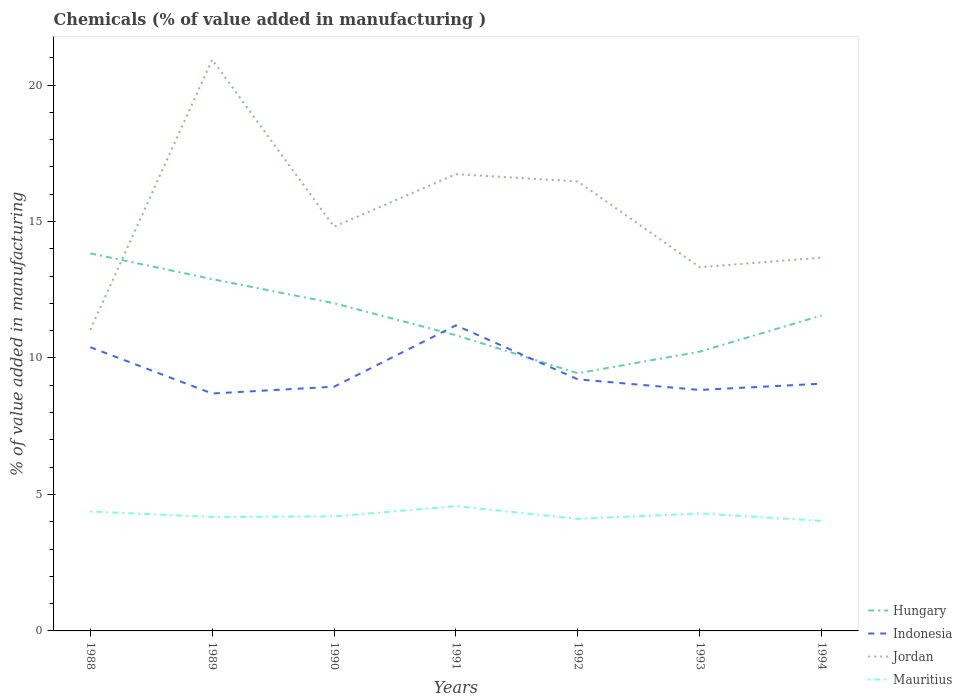Is the number of lines equal to the number of legend labels?
Keep it short and to the point. Yes. Across all years, what is the maximum value added in manufacturing chemicals in Hungary?
Your answer should be very brief. 9.44. What is the total value added in manufacturing chemicals in Hungary in the graph?
Offer a very short reply. -0.79. What is the difference between the highest and the second highest value added in manufacturing chemicals in Indonesia?
Your answer should be compact. 2.5. Is the value added in manufacturing chemicals in Hungary strictly greater than the value added in manufacturing chemicals in Jordan over the years?
Make the answer very short. No. How many lines are there?
Give a very brief answer. 4. Are the values on the major ticks of Y-axis written in scientific E-notation?
Offer a very short reply. No. Does the graph contain any zero values?
Give a very brief answer. No. Does the graph contain grids?
Keep it short and to the point. No. How many legend labels are there?
Provide a succinct answer. 4. How are the legend labels stacked?
Offer a terse response. Vertical. What is the title of the graph?
Give a very brief answer. Chemicals (% of value added in manufacturing ). Does "Belarus" appear as one of the legend labels in the graph?
Provide a short and direct response. No. What is the label or title of the Y-axis?
Offer a very short reply. % of value added in manufacturing. What is the % of value added in manufacturing in Hungary in 1988?
Ensure brevity in your answer.  13.83. What is the % of value added in manufacturing of Indonesia in 1988?
Make the answer very short. 10.4. What is the % of value added in manufacturing in Jordan in 1988?
Offer a terse response. 11.03. What is the % of value added in manufacturing in Mauritius in 1988?
Keep it short and to the point. 4.38. What is the % of value added in manufacturing of Hungary in 1989?
Your response must be concise. 12.89. What is the % of value added in manufacturing in Indonesia in 1989?
Your answer should be compact. 8.7. What is the % of value added in manufacturing in Jordan in 1989?
Offer a terse response. 20.93. What is the % of value added in manufacturing of Mauritius in 1989?
Your response must be concise. 4.17. What is the % of value added in manufacturing of Hungary in 1990?
Make the answer very short. 12.01. What is the % of value added in manufacturing in Indonesia in 1990?
Offer a terse response. 8.95. What is the % of value added in manufacturing of Jordan in 1990?
Your answer should be compact. 14.81. What is the % of value added in manufacturing of Mauritius in 1990?
Your answer should be compact. 4.2. What is the % of value added in manufacturing of Hungary in 1991?
Your answer should be compact. 10.83. What is the % of value added in manufacturing of Indonesia in 1991?
Make the answer very short. 11.2. What is the % of value added in manufacturing of Jordan in 1991?
Offer a terse response. 16.74. What is the % of value added in manufacturing of Mauritius in 1991?
Ensure brevity in your answer.  4.57. What is the % of value added in manufacturing of Hungary in 1992?
Make the answer very short. 9.44. What is the % of value added in manufacturing of Indonesia in 1992?
Provide a short and direct response. 9.22. What is the % of value added in manufacturing of Jordan in 1992?
Your response must be concise. 16.47. What is the % of value added in manufacturing of Mauritius in 1992?
Ensure brevity in your answer.  4.11. What is the % of value added in manufacturing of Hungary in 1993?
Your answer should be compact. 10.23. What is the % of value added in manufacturing of Indonesia in 1993?
Provide a short and direct response. 8.83. What is the % of value added in manufacturing of Jordan in 1993?
Your answer should be very brief. 13.33. What is the % of value added in manufacturing in Mauritius in 1993?
Your answer should be very brief. 4.31. What is the % of value added in manufacturing in Hungary in 1994?
Your answer should be very brief. 11.56. What is the % of value added in manufacturing in Indonesia in 1994?
Provide a short and direct response. 9.06. What is the % of value added in manufacturing in Jordan in 1994?
Your answer should be compact. 13.68. What is the % of value added in manufacturing of Mauritius in 1994?
Your response must be concise. 4.03. Across all years, what is the maximum % of value added in manufacturing of Hungary?
Your answer should be compact. 13.83. Across all years, what is the maximum % of value added in manufacturing in Indonesia?
Offer a very short reply. 11.2. Across all years, what is the maximum % of value added in manufacturing of Jordan?
Make the answer very short. 20.93. Across all years, what is the maximum % of value added in manufacturing in Mauritius?
Provide a short and direct response. 4.57. Across all years, what is the minimum % of value added in manufacturing of Hungary?
Your answer should be compact. 9.44. Across all years, what is the minimum % of value added in manufacturing of Indonesia?
Give a very brief answer. 8.7. Across all years, what is the minimum % of value added in manufacturing of Jordan?
Your answer should be compact. 11.03. Across all years, what is the minimum % of value added in manufacturing in Mauritius?
Ensure brevity in your answer.  4.03. What is the total % of value added in manufacturing of Hungary in the graph?
Provide a succinct answer. 80.8. What is the total % of value added in manufacturing of Indonesia in the graph?
Make the answer very short. 66.35. What is the total % of value added in manufacturing of Jordan in the graph?
Offer a terse response. 106.98. What is the total % of value added in manufacturing of Mauritius in the graph?
Your response must be concise. 29.76. What is the difference between the % of value added in manufacturing in Hungary in 1988 and that in 1989?
Provide a succinct answer. 0.94. What is the difference between the % of value added in manufacturing in Indonesia in 1988 and that in 1989?
Your answer should be very brief. 1.7. What is the difference between the % of value added in manufacturing of Jordan in 1988 and that in 1989?
Offer a very short reply. -9.9. What is the difference between the % of value added in manufacturing in Mauritius in 1988 and that in 1989?
Make the answer very short. 0.2. What is the difference between the % of value added in manufacturing of Hungary in 1988 and that in 1990?
Provide a short and direct response. 1.83. What is the difference between the % of value added in manufacturing of Indonesia in 1988 and that in 1990?
Offer a very short reply. 1.45. What is the difference between the % of value added in manufacturing in Jordan in 1988 and that in 1990?
Make the answer very short. -3.78. What is the difference between the % of value added in manufacturing of Mauritius in 1988 and that in 1990?
Your answer should be compact. 0.18. What is the difference between the % of value added in manufacturing of Hungary in 1988 and that in 1991?
Offer a very short reply. 3. What is the difference between the % of value added in manufacturing of Indonesia in 1988 and that in 1991?
Offer a terse response. -0.8. What is the difference between the % of value added in manufacturing in Jordan in 1988 and that in 1991?
Keep it short and to the point. -5.7. What is the difference between the % of value added in manufacturing in Mauritius in 1988 and that in 1991?
Your response must be concise. -0.2. What is the difference between the % of value added in manufacturing in Hungary in 1988 and that in 1992?
Offer a very short reply. 4.39. What is the difference between the % of value added in manufacturing in Indonesia in 1988 and that in 1992?
Keep it short and to the point. 1.18. What is the difference between the % of value added in manufacturing in Jordan in 1988 and that in 1992?
Offer a terse response. -5.44. What is the difference between the % of value added in manufacturing in Mauritius in 1988 and that in 1992?
Ensure brevity in your answer.  0.27. What is the difference between the % of value added in manufacturing in Hungary in 1988 and that in 1993?
Your answer should be very brief. 3.6. What is the difference between the % of value added in manufacturing in Indonesia in 1988 and that in 1993?
Provide a short and direct response. 1.57. What is the difference between the % of value added in manufacturing of Jordan in 1988 and that in 1993?
Offer a very short reply. -2.29. What is the difference between the % of value added in manufacturing of Mauritius in 1988 and that in 1993?
Make the answer very short. 0.07. What is the difference between the % of value added in manufacturing in Hungary in 1988 and that in 1994?
Provide a succinct answer. 2.28. What is the difference between the % of value added in manufacturing in Indonesia in 1988 and that in 1994?
Offer a terse response. 1.34. What is the difference between the % of value added in manufacturing in Jordan in 1988 and that in 1994?
Keep it short and to the point. -2.65. What is the difference between the % of value added in manufacturing of Mauritius in 1988 and that in 1994?
Provide a short and direct response. 0.34. What is the difference between the % of value added in manufacturing in Hungary in 1989 and that in 1990?
Your answer should be very brief. 0.88. What is the difference between the % of value added in manufacturing in Indonesia in 1989 and that in 1990?
Provide a succinct answer. -0.25. What is the difference between the % of value added in manufacturing in Jordan in 1989 and that in 1990?
Offer a very short reply. 6.12. What is the difference between the % of value added in manufacturing in Mauritius in 1989 and that in 1990?
Your answer should be compact. -0.02. What is the difference between the % of value added in manufacturing in Hungary in 1989 and that in 1991?
Ensure brevity in your answer.  2.06. What is the difference between the % of value added in manufacturing of Indonesia in 1989 and that in 1991?
Make the answer very short. -2.5. What is the difference between the % of value added in manufacturing of Jordan in 1989 and that in 1991?
Offer a terse response. 4.2. What is the difference between the % of value added in manufacturing in Mauritius in 1989 and that in 1991?
Provide a succinct answer. -0.4. What is the difference between the % of value added in manufacturing in Hungary in 1989 and that in 1992?
Provide a short and direct response. 3.45. What is the difference between the % of value added in manufacturing of Indonesia in 1989 and that in 1992?
Your response must be concise. -0.52. What is the difference between the % of value added in manufacturing in Jordan in 1989 and that in 1992?
Provide a short and direct response. 4.46. What is the difference between the % of value added in manufacturing of Mauritius in 1989 and that in 1992?
Your response must be concise. 0.07. What is the difference between the % of value added in manufacturing in Hungary in 1989 and that in 1993?
Offer a terse response. 2.66. What is the difference between the % of value added in manufacturing of Indonesia in 1989 and that in 1993?
Ensure brevity in your answer.  -0.13. What is the difference between the % of value added in manufacturing in Jordan in 1989 and that in 1993?
Your answer should be very brief. 7.61. What is the difference between the % of value added in manufacturing of Mauritius in 1989 and that in 1993?
Offer a terse response. -0.13. What is the difference between the % of value added in manufacturing of Hungary in 1989 and that in 1994?
Your answer should be compact. 1.33. What is the difference between the % of value added in manufacturing in Indonesia in 1989 and that in 1994?
Make the answer very short. -0.36. What is the difference between the % of value added in manufacturing of Jordan in 1989 and that in 1994?
Provide a succinct answer. 7.25. What is the difference between the % of value added in manufacturing in Mauritius in 1989 and that in 1994?
Your response must be concise. 0.14. What is the difference between the % of value added in manufacturing of Hungary in 1990 and that in 1991?
Give a very brief answer. 1.17. What is the difference between the % of value added in manufacturing of Indonesia in 1990 and that in 1991?
Provide a succinct answer. -2.25. What is the difference between the % of value added in manufacturing in Jordan in 1990 and that in 1991?
Offer a very short reply. -1.93. What is the difference between the % of value added in manufacturing of Mauritius in 1990 and that in 1991?
Provide a succinct answer. -0.38. What is the difference between the % of value added in manufacturing of Hungary in 1990 and that in 1992?
Make the answer very short. 2.57. What is the difference between the % of value added in manufacturing of Indonesia in 1990 and that in 1992?
Your answer should be compact. -0.27. What is the difference between the % of value added in manufacturing in Jordan in 1990 and that in 1992?
Your response must be concise. -1.66. What is the difference between the % of value added in manufacturing in Mauritius in 1990 and that in 1992?
Ensure brevity in your answer.  0.09. What is the difference between the % of value added in manufacturing of Hungary in 1990 and that in 1993?
Your response must be concise. 1.77. What is the difference between the % of value added in manufacturing of Indonesia in 1990 and that in 1993?
Your response must be concise. 0.12. What is the difference between the % of value added in manufacturing in Jordan in 1990 and that in 1993?
Provide a succinct answer. 1.48. What is the difference between the % of value added in manufacturing in Mauritius in 1990 and that in 1993?
Offer a terse response. -0.11. What is the difference between the % of value added in manufacturing in Hungary in 1990 and that in 1994?
Provide a short and direct response. 0.45. What is the difference between the % of value added in manufacturing of Indonesia in 1990 and that in 1994?
Give a very brief answer. -0.11. What is the difference between the % of value added in manufacturing of Jordan in 1990 and that in 1994?
Offer a terse response. 1.13. What is the difference between the % of value added in manufacturing of Mauritius in 1990 and that in 1994?
Offer a terse response. 0.16. What is the difference between the % of value added in manufacturing in Hungary in 1991 and that in 1992?
Your answer should be very brief. 1.39. What is the difference between the % of value added in manufacturing in Indonesia in 1991 and that in 1992?
Give a very brief answer. 1.98. What is the difference between the % of value added in manufacturing of Jordan in 1991 and that in 1992?
Your answer should be compact. 0.27. What is the difference between the % of value added in manufacturing in Mauritius in 1991 and that in 1992?
Provide a short and direct response. 0.47. What is the difference between the % of value added in manufacturing of Hungary in 1991 and that in 1993?
Provide a short and direct response. 0.6. What is the difference between the % of value added in manufacturing in Indonesia in 1991 and that in 1993?
Provide a succinct answer. 2.37. What is the difference between the % of value added in manufacturing in Jordan in 1991 and that in 1993?
Your answer should be very brief. 3.41. What is the difference between the % of value added in manufacturing in Mauritius in 1991 and that in 1993?
Your answer should be compact. 0.27. What is the difference between the % of value added in manufacturing in Hungary in 1991 and that in 1994?
Ensure brevity in your answer.  -0.72. What is the difference between the % of value added in manufacturing of Indonesia in 1991 and that in 1994?
Make the answer very short. 2.14. What is the difference between the % of value added in manufacturing in Jordan in 1991 and that in 1994?
Make the answer very short. 3.06. What is the difference between the % of value added in manufacturing of Mauritius in 1991 and that in 1994?
Make the answer very short. 0.54. What is the difference between the % of value added in manufacturing in Hungary in 1992 and that in 1993?
Your answer should be compact. -0.79. What is the difference between the % of value added in manufacturing of Indonesia in 1992 and that in 1993?
Provide a succinct answer. 0.39. What is the difference between the % of value added in manufacturing of Jordan in 1992 and that in 1993?
Provide a succinct answer. 3.14. What is the difference between the % of value added in manufacturing in Mauritius in 1992 and that in 1993?
Offer a terse response. -0.2. What is the difference between the % of value added in manufacturing in Hungary in 1992 and that in 1994?
Provide a succinct answer. -2.12. What is the difference between the % of value added in manufacturing of Indonesia in 1992 and that in 1994?
Offer a terse response. 0.16. What is the difference between the % of value added in manufacturing in Jordan in 1992 and that in 1994?
Give a very brief answer. 2.79. What is the difference between the % of value added in manufacturing of Mauritius in 1992 and that in 1994?
Offer a terse response. 0.07. What is the difference between the % of value added in manufacturing in Hungary in 1993 and that in 1994?
Ensure brevity in your answer.  -1.33. What is the difference between the % of value added in manufacturing in Indonesia in 1993 and that in 1994?
Ensure brevity in your answer.  -0.23. What is the difference between the % of value added in manufacturing in Jordan in 1993 and that in 1994?
Provide a succinct answer. -0.35. What is the difference between the % of value added in manufacturing in Mauritius in 1993 and that in 1994?
Keep it short and to the point. 0.27. What is the difference between the % of value added in manufacturing of Hungary in 1988 and the % of value added in manufacturing of Indonesia in 1989?
Give a very brief answer. 5.13. What is the difference between the % of value added in manufacturing in Hungary in 1988 and the % of value added in manufacturing in Jordan in 1989?
Provide a succinct answer. -7.1. What is the difference between the % of value added in manufacturing in Hungary in 1988 and the % of value added in manufacturing in Mauritius in 1989?
Give a very brief answer. 9.66. What is the difference between the % of value added in manufacturing in Indonesia in 1988 and the % of value added in manufacturing in Jordan in 1989?
Make the answer very short. -10.54. What is the difference between the % of value added in manufacturing in Indonesia in 1988 and the % of value added in manufacturing in Mauritius in 1989?
Make the answer very short. 6.22. What is the difference between the % of value added in manufacturing of Jordan in 1988 and the % of value added in manufacturing of Mauritius in 1989?
Provide a succinct answer. 6.86. What is the difference between the % of value added in manufacturing of Hungary in 1988 and the % of value added in manufacturing of Indonesia in 1990?
Your answer should be compact. 4.89. What is the difference between the % of value added in manufacturing of Hungary in 1988 and the % of value added in manufacturing of Jordan in 1990?
Make the answer very short. -0.97. What is the difference between the % of value added in manufacturing in Hungary in 1988 and the % of value added in manufacturing in Mauritius in 1990?
Your response must be concise. 9.64. What is the difference between the % of value added in manufacturing in Indonesia in 1988 and the % of value added in manufacturing in Jordan in 1990?
Ensure brevity in your answer.  -4.41. What is the difference between the % of value added in manufacturing of Indonesia in 1988 and the % of value added in manufacturing of Mauritius in 1990?
Offer a terse response. 6.2. What is the difference between the % of value added in manufacturing of Jordan in 1988 and the % of value added in manufacturing of Mauritius in 1990?
Give a very brief answer. 6.84. What is the difference between the % of value added in manufacturing of Hungary in 1988 and the % of value added in manufacturing of Indonesia in 1991?
Give a very brief answer. 2.64. What is the difference between the % of value added in manufacturing in Hungary in 1988 and the % of value added in manufacturing in Jordan in 1991?
Your answer should be very brief. -2.9. What is the difference between the % of value added in manufacturing in Hungary in 1988 and the % of value added in manufacturing in Mauritius in 1991?
Ensure brevity in your answer.  9.26. What is the difference between the % of value added in manufacturing in Indonesia in 1988 and the % of value added in manufacturing in Jordan in 1991?
Ensure brevity in your answer.  -6.34. What is the difference between the % of value added in manufacturing of Indonesia in 1988 and the % of value added in manufacturing of Mauritius in 1991?
Provide a short and direct response. 5.82. What is the difference between the % of value added in manufacturing of Jordan in 1988 and the % of value added in manufacturing of Mauritius in 1991?
Ensure brevity in your answer.  6.46. What is the difference between the % of value added in manufacturing of Hungary in 1988 and the % of value added in manufacturing of Indonesia in 1992?
Offer a terse response. 4.62. What is the difference between the % of value added in manufacturing in Hungary in 1988 and the % of value added in manufacturing in Jordan in 1992?
Your answer should be compact. -2.63. What is the difference between the % of value added in manufacturing of Hungary in 1988 and the % of value added in manufacturing of Mauritius in 1992?
Make the answer very short. 9.73. What is the difference between the % of value added in manufacturing of Indonesia in 1988 and the % of value added in manufacturing of Jordan in 1992?
Your answer should be very brief. -6.07. What is the difference between the % of value added in manufacturing of Indonesia in 1988 and the % of value added in manufacturing of Mauritius in 1992?
Keep it short and to the point. 6.29. What is the difference between the % of value added in manufacturing in Jordan in 1988 and the % of value added in manufacturing in Mauritius in 1992?
Offer a very short reply. 6.93. What is the difference between the % of value added in manufacturing of Hungary in 1988 and the % of value added in manufacturing of Indonesia in 1993?
Keep it short and to the point. 5. What is the difference between the % of value added in manufacturing of Hungary in 1988 and the % of value added in manufacturing of Jordan in 1993?
Keep it short and to the point. 0.51. What is the difference between the % of value added in manufacturing in Hungary in 1988 and the % of value added in manufacturing in Mauritius in 1993?
Provide a succinct answer. 9.53. What is the difference between the % of value added in manufacturing of Indonesia in 1988 and the % of value added in manufacturing of Jordan in 1993?
Your response must be concise. -2.93. What is the difference between the % of value added in manufacturing of Indonesia in 1988 and the % of value added in manufacturing of Mauritius in 1993?
Provide a succinct answer. 6.09. What is the difference between the % of value added in manufacturing of Jordan in 1988 and the % of value added in manufacturing of Mauritius in 1993?
Give a very brief answer. 6.73. What is the difference between the % of value added in manufacturing of Hungary in 1988 and the % of value added in manufacturing of Indonesia in 1994?
Provide a short and direct response. 4.77. What is the difference between the % of value added in manufacturing of Hungary in 1988 and the % of value added in manufacturing of Jordan in 1994?
Provide a short and direct response. 0.16. What is the difference between the % of value added in manufacturing in Hungary in 1988 and the % of value added in manufacturing in Mauritius in 1994?
Offer a terse response. 9.8. What is the difference between the % of value added in manufacturing of Indonesia in 1988 and the % of value added in manufacturing of Jordan in 1994?
Provide a short and direct response. -3.28. What is the difference between the % of value added in manufacturing of Indonesia in 1988 and the % of value added in manufacturing of Mauritius in 1994?
Your answer should be very brief. 6.36. What is the difference between the % of value added in manufacturing of Jordan in 1988 and the % of value added in manufacturing of Mauritius in 1994?
Ensure brevity in your answer.  7. What is the difference between the % of value added in manufacturing of Hungary in 1989 and the % of value added in manufacturing of Indonesia in 1990?
Give a very brief answer. 3.94. What is the difference between the % of value added in manufacturing of Hungary in 1989 and the % of value added in manufacturing of Jordan in 1990?
Your answer should be compact. -1.92. What is the difference between the % of value added in manufacturing in Hungary in 1989 and the % of value added in manufacturing in Mauritius in 1990?
Make the answer very short. 8.69. What is the difference between the % of value added in manufacturing in Indonesia in 1989 and the % of value added in manufacturing in Jordan in 1990?
Ensure brevity in your answer.  -6.11. What is the difference between the % of value added in manufacturing of Indonesia in 1989 and the % of value added in manufacturing of Mauritius in 1990?
Make the answer very short. 4.5. What is the difference between the % of value added in manufacturing of Jordan in 1989 and the % of value added in manufacturing of Mauritius in 1990?
Your answer should be very brief. 16.74. What is the difference between the % of value added in manufacturing in Hungary in 1989 and the % of value added in manufacturing in Indonesia in 1991?
Give a very brief answer. 1.69. What is the difference between the % of value added in manufacturing in Hungary in 1989 and the % of value added in manufacturing in Jordan in 1991?
Your response must be concise. -3.85. What is the difference between the % of value added in manufacturing of Hungary in 1989 and the % of value added in manufacturing of Mauritius in 1991?
Offer a terse response. 8.32. What is the difference between the % of value added in manufacturing in Indonesia in 1989 and the % of value added in manufacturing in Jordan in 1991?
Your response must be concise. -8.04. What is the difference between the % of value added in manufacturing in Indonesia in 1989 and the % of value added in manufacturing in Mauritius in 1991?
Offer a very short reply. 4.13. What is the difference between the % of value added in manufacturing of Jordan in 1989 and the % of value added in manufacturing of Mauritius in 1991?
Make the answer very short. 16.36. What is the difference between the % of value added in manufacturing in Hungary in 1989 and the % of value added in manufacturing in Indonesia in 1992?
Offer a terse response. 3.67. What is the difference between the % of value added in manufacturing in Hungary in 1989 and the % of value added in manufacturing in Jordan in 1992?
Your answer should be very brief. -3.58. What is the difference between the % of value added in manufacturing in Hungary in 1989 and the % of value added in manufacturing in Mauritius in 1992?
Offer a terse response. 8.78. What is the difference between the % of value added in manufacturing of Indonesia in 1989 and the % of value added in manufacturing of Jordan in 1992?
Keep it short and to the point. -7.77. What is the difference between the % of value added in manufacturing of Indonesia in 1989 and the % of value added in manufacturing of Mauritius in 1992?
Provide a short and direct response. 4.59. What is the difference between the % of value added in manufacturing in Jordan in 1989 and the % of value added in manufacturing in Mauritius in 1992?
Offer a terse response. 16.83. What is the difference between the % of value added in manufacturing in Hungary in 1989 and the % of value added in manufacturing in Indonesia in 1993?
Offer a very short reply. 4.06. What is the difference between the % of value added in manufacturing of Hungary in 1989 and the % of value added in manufacturing of Jordan in 1993?
Offer a very short reply. -0.44. What is the difference between the % of value added in manufacturing in Hungary in 1989 and the % of value added in manufacturing in Mauritius in 1993?
Your response must be concise. 8.59. What is the difference between the % of value added in manufacturing of Indonesia in 1989 and the % of value added in manufacturing of Jordan in 1993?
Your answer should be compact. -4.63. What is the difference between the % of value added in manufacturing of Indonesia in 1989 and the % of value added in manufacturing of Mauritius in 1993?
Your answer should be compact. 4.39. What is the difference between the % of value added in manufacturing in Jordan in 1989 and the % of value added in manufacturing in Mauritius in 1993?
Your answer should be very brief. 16.63. What is the difference between the % of value added in manufacturing of Hungary in 1989 and the % of value added in manufacturing of Indonesia in 1994?
Offer a terse response. 3.83. What is the difference between the % of value added in manufacturing in Hungary in 1989 and the % of value added in manufacturing in Jordan in 1994?
Provide a succinct answer. -0.79. What is the difference between the % of value added in manufacturing in Hungary in 1989 and the % of value added in manufacturing in Mauritius in 1994?
Your answer should be very brief. 8.86. What is the difference between the % of value added in manufacturing of Indonesia in 1989 and the % of value added in manufacturing of Jordan in 1994?
Ensure brevity in your answer.  -4.98. What is the difference between the % of value added in manufacturing in Indonesia in 1989 and the % of value added in manufacturing in Mauritius in 1994?
Your answer should be compact. 4.67. What is the difference between the % of value added in manufacturing of Jordan in 1989 and the % of value added in manufacturing of Mauritius in 1994?
Give a very brief answer. 16.9. What is the difference between the % of value added in manufacturing of Hungary in 1990 and the % of value added in manufacturing of Indonesia in 1991?
Your answer should be very brief. 0.81. What is the difference between the % of value added in manufacturing of Hungary in 1990 and the % of value added in manufacturing of Jordan in 1991?
Your answer should be compact. -4.73. What is the difference between the % of value added in manufacturing in Hungary in 1990 and the % of value added in manufacturing in Mauritius in 1991?
Make the answer very short. 7.43. What is the difference between the % of value added in manufacturing in Indonesia in 1990 and the % of value added in manufacturing in Jordan in 1991?
Provide a short and direct response. -7.79. What is the difference between the % of value added in manufacturing in Indonesia in 1990 and the % of value added in manufacturing in Mauritius in 1991?
Give a very brief answer. 4.37. What is the difference between the % of value added in manufacturing of Jordan in 1990 and the % of value added in manufacturing of Mauritius in 1991?
Offer a very short reply. 10.23. What is the difference between the % of value added in manufacturing in Hungary in 1990 and the % of value added in manufacturing in Indonesia in 1992?
Offer a very short reply. 2.79. What is the difference between the % of value added in manufacturing in Hungary in 1990 and the % of value added in manufacturing in Jordan in 1992?
Make the answer very short. -4.46. What is the difference between the % of value added in manufacturing of Hungary in 1990 and the % of value added in manufacturing of Mauritius in 1992?
Give a very brief answer. 7.9. What is the difference between the % of value added in manufacturing of Indonesia in 1990 and the % of value added in manufacturing of Jordan in 1992?
Make the answer very short. -7.52. What is the difference between the % of value added in manufacturing in Indonesia in 1990 and the % of value added in manufacturing in Mauritius in 1992?
Your response must be concise. 4.84. What is the difference between the % of value added in manufacturing of Jordan in 1990 and the % of value added in manufacturing of Mauritius in 1992?
Your answer should be very brief. 10.7. What is the difference between the % of value added in manufacturing in Hungary in 1990 and the % of value added in manufacturing in Indonesia in 1993?
Ensure brevity in your answer.  3.18. What is the difference between the % of value added in manufacturing of Hungary in 1990 and the % of value added in manufacturing of Jordan in 1993?
Provide a short and direct response. -1.32. What is the difference between the % of value added in manufacturing in Hungary in 1990 and the % of value added in manufacturing in Mauritius in 1993?
Ensure brevity in your answer.  7.7. What is the difference between the % of value added in manufacturing in Indonesia in 1990 and the % of value added in manufacturing in Jordan in 1993?
Give a very brief answer. -4.38. What is the difference between the % of value added in manufacturing of Indonesia in 1990 and the % of value added in manufacturing of Mauritius in 1993?
Give a very brief answer. 4.64. What is the difference between the % of value added in manufacturing in Jordan in 1990 and the % of value added in manufacturing in Mauritius in 1993?
Your answer should be compact. 10.5. What is the difference between the % of value added in manufacturing of Hungary in 1990 and the % of value added in manufacturing of Indonesia in 1994?
Offer a very short reply. 2.95. What is the difference between the % of value added in manufacturing in Hungary in 1990 and the % of value added in manufacturing in Jordan in 1994?
Your answer should be very brief. -1.67. What is the difference between the % of value added in manufacturing of Hungary in 1990 and the % of value added in manufacturing of Mauritius in 1994?
Offer a very short reply. 7.97. What is the difference between the % of value added in manufacturing of Indonesia in 1990 and the % of value added in manufacturing of Jordan in 1994?
Make the answer very short. -4.73. What is the difference between the % of value added in manufacturing in Indonesia in 1990 and the % of value added in manufacturing in Mauritius in 1994?
Your answer should be compact. 4.92. What is the difference between the % of value added in manufacturing of Jordan in 1990 and the % of value added in manufacturing of Mauritius in 1994?
Give a very brief answer. 10.78. What is the difference between the % of value added in manufacturing in Hungary in 1991 and the % of value added in manufacturing in Indonesia in 1992?
Provide a short and direct response. 1.62. What is the difference between the % of value added in manufacturing of Hungary in 1991 and the % of value added in manufacturing of Jordan in 1992?
Offer a very short reply. -5.63. What is the difference between the % of value added in manufacturing in Hungary in 1991 and the % of value added in manufacturing in Mauritius in 1992?
Offer a terse response. 6.73. What is the difference between the % of value added in manufacturing of Indonesia in 1991 and the % of value added in manufacturing of Jordan in 1992?
Provide a succinct answer. -5.27. What is the difference between the % of value added in manufacturing of Indonesia in 1991 and the % of value added in manufacturing of Mauritius in 1992?
Provide a succinct answer. 7.09. What is the difference between the % of value added in manufacturing in Jordan in 1991 and the % of value added in manufacturing in Mauritius in 1992?
Make the answer very short. 12.63. What is the difference between the % of value added in manufacturing of Hungary in 1991 and the % of value added in manufacturing of Indonesia in 1993?
Your response must be concise. 2.01. What is the difference between the % of value added in manufacturing of Hungary in 1991 and the % of value added in manufacturing of Jordan in 1993?
Give a very brief answer. -2.49. What is the difference between the % of value added in manufacturing of Hungary in 1991 and the % of value added in manufacturing of Mauritius in 1993?
Offer a very short reply. 6.53. What is the difference between the % of value added in manufacturing of Indonesia in 1991 and the % of value added in manufacturing of Jordan in 1993?
Give a very brief answer. -2.13. What is the difference between the % of value added in manufacturing in Indonesia in 1991 and the % of value added in manufacturing in Mauritius in 1993?
Ensure brevity in your answer.  6.89. What is the difference between the % of value added in manufacturing in Jordan in 1991 and the % of value added in manufacturing in Mauritius in 1993?
Keep it short and to the point. 12.43. What is the difference between the % of value added in manufacturing in Hungary in 1991 and the % of value added in manufacturing in Indonesia in 1994?
Offer a very short reply. 1.77. What is the difference between the % of value added in manufacturing in Hungary in 1991 and the % of value added in manufacturing in Jordan in 1994?
Your answer should be compact. -2.84. What is the difference between the % of value added in manufacturing of Hungary in 1991 and the % of value added in manufacturing of Mauritius in 1994?
Your answer should be very brief. 6.8. What is the difference between the % of value added in manufacturing in Indonesia in 1991 and the % of value added in manufacturing in Jordan in 1994?
Your answer should be very brief. -2.48. What is the difference between the % of value added in manufacturing of Indonesia in 1991 and the % of value added in manufacturing of Mauritius in 1994?
Your response must be concise. 7.16. What is the difference between the % of value added in manufacturing in Jordan in 1991 and the % of value added in manufacturing in Mauritius in 1994?
Offer a terse response. 12.7. What is the difference between the % of value added in manufacturing in Hungary in 1992 and the % of value added in manufacturing in Indonesia in 1993?
Your response must be concise. 0.61. What is the difference between the % of value added in manufacturing in Hungary in 1992 and the % of value added in manufacturing in Jordan in 1993?
Offer a terse response. -3.88. What is the difference between the % of value added in manufacturing of Hungary in 1992 and the % of value added in manufacturing of Mauritius in 1993?
Provide a short and direct response. 5.14. What is the difference between the % of value added in manufacturing in Indonesia in 1992 and the % of value added in manufacturing in Jordan in 1993?
Ensure brevity in your answer.  -4.11. What is the difference between the % of value added in manufacturing in Indonesia in 1992 and the % of value added in manufacturing in Mauritius in 1993?
Make the answer very short. 4.91. What is the difference between the % of value added in manufacturing of Jordan in 1992 and the % of value added in manufacturing of Mauritius in 1993?
Offer a very short reply. 12.16. What is the difference between the % of value added in manufacturing of Hungary in 1992 and the % of value added in manufacturing of Indonesia in 1994?
Provide a short and direct response. 0.38. What is the difference between the % of value added in manufacturing in Hungary in 1992 and the % of value added in manufacturing in Jordan in 1994?
Ensure brevity in your answer.  -4.24. What is the difference between the % of value added in manufacturing of Hungary in 1992 and the % of value added in manufacturing of Mauritius in 1994?
Ensure brevity in your answer.  5.41. What is the difference between the % of value added in manufacturing of Indonesia in 1992 and the % of value added in manufacturing of Jordan in 1994?
Your answer should be compact. -4.46. What is the difference between the % of value added in manufacturing of Indonesia in 1992 and the % of value added in manufacturing of Mauritius in 1994?
Ensure brevity in your answer.  5.19. What is the difference between the % of value added in manufacturing in Jordan in 1992 and the % of value added in manufacturing in Mauritius in 1994?
Ensure brevity in your answer.  12.44. What is the difference between the % of value added in manufacturing in Hungary in 1993 and the % of value added in manufacturing in Indonesia in 1994?
Ensure brevity in your answer.  1.17. What is the difference between the % of value added in manufacturing in Hungary in 1993 and the % of value added in manufacturing in Jordan in 1994?
Your answer should be very brief. -3.45. What is the difference between the % of value added in manufacturing of Hungary in 1993 and the % of value added in manufacturing of Mauritius in 1994?
Offer a very short reply. 6.2. What is the difference between the % of value added in manufacturing in Indonesia in 1993 and the % of value added in manufacturing in Jordan in 1994?
Ensure brevity in your answer.  -4.85. What is the difference between the % of value added in manufacturing of Indonesia in 1993 and the % of value added in manufacturing of Mauritius in 1994?
Your response must be concise. 4.8. What is the difference between the % of value added in manufacturing of Jordan in 1993 and the % of value added in manufacturing of Mauritius in 1994?
Provide a short and direct response. 9.29. What is the average % of value added in manufacturing in Hungary per year?
Offer a terse response. 11.54. What is the average % of value added in manufacturing in Indonesia per year?
Provide a short and direct response. 9.48. What is the average % of value added in manufacturing of Jordan per year?
Keep it short and to the point. 15.28. What is the average % of value added in manufacturing in Mauritius per year?
Ensure brevity in your answer.  4.25. In the year 1988, what is the difference between the % of value added in manufacturing in Hungary and % of value added in manufacturing in Indonesia?
Ensure brevity in your answer.  3.44. In the year 1988, what is the difference between the % of value added in manufacturing in Hungary and % of value added in manufacturing in Jordan?
Provide a short and direct response. 2.8. In the year 1988, what is the difference between the % of value added in manufacturing in Hungary and % of value added in manufacturing in Mauritius?
Offer a very short reply. 9.46. In the year 1988, what is the difference between the % of value added in manufacturing of Indonesia and % of value added in manufacturing of Jordan?
Make the answer very short. -0.64. In the year 1988, what is the difference between the % of value added in manufacturing of Indonesia and % of value added in manufacturing of Mauritius?
Offer a terse response. 6.02. In the year 1988, what is the difference between the % of value added in manufacturing of Jordan and % of value added in manufacturing of Mauritius?
Your answer should be compact. 6.66. In the year 1989, what is the difference between the % of value added in manufacturing of Hungary and % of value added in manufacturing of Indonesia?
Your answer should be very brief. 4.19. In the year 1989, what is the difference between the % of value added in manufacturing in Hungary and % of value added in manufacturing in Jordan?
Offer a very short reply. -8.04. In the year 1989, what is the difference between the % of value added in manufacturing in Hungary and % of value added in manufacturing in Mauritius?
Keep it short and to the point. 8.72. In the year 1989, what is the difference between the % of value added in manufacturing of Indonesia and % of value added in manufacturing of Jordan?
Provide a succinct answer. -12.23. In the year 1989, what is the difference between the % of value added in manufacturing in Indonesia and % of value added in manufacturing in Mauritius?
Provide a succinct answer. 4.52. In the year 1989, what is the difference between the % of value added in manufacturing in Jordan and % of value added in manufacturing in Mauritius?
Keep it short and to the point. 16.76. In the year 1990, what is the difference between the % of value added in manufacturing of Hungary and % of value added in manufacturing of Indonesia?
Ensure brevity in your answer.  3.06. In the year 1990, what is the difference between the % of value added in manufacturing of Hungary and % of value added in manufacturing of Jordan?
Your answer should be compact. -2.8. In the year 1990, what is the difference between the % of value added in manufacturing in Hungary and % of value added in manufacturing in Mauritius?
Make the answer very short. 7.81. In the year 1990, what is the difference between the % of value added in manufacturing in Indonesia and % of value added in manufacturing in Jordan?
Provide a short and direct response. -5.86. In the year 1990, what is the difference between the % of value added in manufacturing of Indonesia and % of value added in manufacturing of Mauritius?
Make the answer very short. 4.75. In the year 1990, what is the difference between the % of value added in manufacturing in Jordan and % of value added in manufacturing in Mauritius?
Give a very brief answer. 10.61. In the year 1991, what is the difference between the % of value added in manufacturing of Hungary and % of value added in manufacturing of Indonesia?
Ensure brevity in your answer.  -0.36. In the year 1991, what is the difference between the % of value added in manufacturing of Hungary and % of value added in manufacturing of Jordan?
Ensure brevity in your answer.  -5.9. In the year 1991, what is the difference between the % of value added in manufacturing in Hungary and % of value added in manufacturing in Mauritius?
Offer a very short reply. 6.26. In the year 1991, what is the difference between the % of value added in manufacturing in Indonesia and % of value added in manufacturing in Jordan?
Your answer should be compact. -5.54. In the year 1991, what is the difference between the % of value added in manufacturing in Indonesia and % of value added in manufacturing in Mauritius?
Give a very brief answer. 6.62. In the year 1991, what is the difference between the % of value added in manufacturing in Jordan and % of value added in manufacturing in Mauritius?
Your answer should be very brief. 12.16. In the year 1992, what is the difference between the % of value added in manufacturing of Hungary and % of value added in manufacturing of Indonesia?
Your answer should be compact. 0.22. In the year 1992, what is the difference between the % of value added in manufacturing of Hungary and % of value added in manufacturing of Jordan?
Your answer should be compact. -7.03. In the year 1992, what is the difference between the % of value added in manufacturing of Hungary and % of value added in manufacturing of Mauritius?
Keep it short and to the point. 5.34. In the year 1992, what is the difference between the % of value added in manufacturing in Indonesia and % of value added in manufacturing in Jordan?
Offer a terse response. -7.25. In the year 1992, what is the difference between the % of value added in manufacturing in Indonesia and % of value added in manufacturing in Mauritius?
Provide a succinct answer. 5.11. In the year 1992, what is the difference between the % of value added in manufacturing of Jordan and % of value added in manufacturing of Mauritius?
Provide a short and direct response. 12.36. In the year 1993, what is the difference between the % of value added in manufacturing of Hungary and % of value added in manufacturing of Indonesia?
Your answer should be very brief. 1.4. In the year 1993, what is the difference between the % of value added in manufacturing of Hungary and % of value added in manufacturing of Jordan?
Provide a succinct answer. -3.09. In the year 1993, what is the difference between the % of value added in manufacturing of Hungary and % of value added in manufacturing of Mauritius?
Offer a very short reply. 5.93. In the year 1993, what is the difference between the % of value added in manufacturing in Indonesia and % of value added in manufacturing in Jordan?
Give a very brief answer. -4.5. In the year 1993, what is the difference between the % of value added in manufacturing in Indonesia and % of value added in manufacturing in Mauritius?
Keep it short and to the point. 4.52. In the year 1993, what is the difference between the % of value added in manufacturing in Jordan and % of value added in manufacturing in Mauritius?
Your answer should be compact. 9.02. In the year 1994, what is the difference between the % of value added in manufacturing in Hungary and % of value added in manufacturing in Indonesia?
Your answer should be compact. 2.5. In the year 1994, what is the difference between the % of value added in manufacturing of Hungary and % of value added in manufacturing of Jordan?
Give a very brief answer. -2.12. In the year 1994, what is the difference between the % of value added in manufacturing in Hungary and % of value added in manufacturing in Mauritius?
Your response must be concise. 7.53. In the year 1994, what is the difference between the % of value added in manufacturing in Indonesia and % of value added in manufacturing in Jordan?
Provide a succinct answer. -4.62. In the year 1994, what is the difference between the % of value added in manufacturing in Indonesia and % of value added in manufacturing in Mauritius?
Offer a very short reply. 5.03. In the year 1994, what is the difference between the % of value added in manufacturing in Jordan and % of value added in manufacturing in Mauritius?
Give a very brief answer. 9.65. What is the ratio of the % of value added in manufacturing of Hungary in 1988 to that in 1989?
Give a very brief answer. 1.07. What is the ratio of the % of value added in manufacturing in Indonesia in 1988 to that in 1989?
Your answer should be compact. 1.2. What is the ratio of the % of value added in manufacturing of Jordan in 1988 to that in 1989?
Your response must be concise. 0.53. What is the ratio of the % of value added in manufacturing in Mauritius in 1988 to that in 1989?
Ensure brevity in your answer.  1.05. What is the ratio of the % of value added in manufacturing of Hungary in 1988 to that in 1990?
Your answer should be compact. 1.15. What is the ratio of the % of value added in manufacturing of Indonesia in 1988 to that in 1990?
Your answer should be very brief. 1.16. What is the ratio of the % of value added in manufacturing in Jordan in 1988 to that in 1990?
Give a very brief answer. 0.75. What is the ratio of the % of value added in manufacturing of Mauritius in 1988 to that in 1990?
Keep it short and to the point. 1.04. What is the ratio of the % of value added in manufacturing of Hungary in 1988 to that in 1991?
Provide a short and direct response. 1.28. What is the ratio of the % of value added in manufacturing of Indonesia in 1988 to that in 1991?
Provide a short and direct response. 0.93. What is the ratio of the % of value added in manufacturing in Jordan in 1988 to that in 1991?
Your response must be concise. 0.66. What is the ratio of the % of value added in manufacturing of Mauritius in 1988 to that in 1991?
Keep it short and to the point. 0.96. What is the ratio of the % of value added in manufacturing in Hungary in 1988 to that in 1992?
Provide a succinct answer. 1.47. What is the ratio of the % of value added in manufacturing of Indonesia in 1988 to that in 1992?
Provide a short and direct response. 1.13. What is the ratio of the % of value added in manufacturing in Jordan in 1988 to that in 1992?
Your response must be concise. 0.67. What is the ratio of the % of value added in manufacturing of Mauritius in 1988 to that in 1992?
Your response must be concise. 1.07. What is the ratio of the % of value added in manufacturing of Hungary in 1988 to that in 1993?
Your answer should be very brief. 1.35. What is the ratio of the % of value added in manufacturing of Indonesia in 1988 to that in 1993?
Keep it short and to the point. 1.18. What is the ratio of the % of value added in manufacturing of Jordan in 1988 to that in 1993?
Provide a short and direct response. 0.83. What is the ratio of the % of value added in manufacturing in Mauritius in 1988 to that in 1993?
Keep it short and to the point. 1.02. What is the ratio of the % of value added in manufacturing in Hungary in 1988 to that in 1994?
Give a very brief answer. 1.2. What is the ratio of the % of value added in manufacturing of Indonesia in 1988 to that in 1994?
Provide a succinct answer. 1.15. What is the ratio of the % of value added in manufacturing in Jordan in 1988 to that in 1994?
Your response must be concise. 0.81. What is the ratio of the % of value added in manufacturing of Mauritius in 1988 to that in 1994?
Your response must be concise. 1.09. What is the ratio of the % of value added in manufacturing in Hungary in 1989 to that in 1990?
Keep it short and to the point. 1.07. What is the ratio of the % of value added in manufacturing in Indonesia in 1989 to that in 1990?
Your response must be concise. 0.97. What is the ratio of the % of value added in manufacturing of Jordan in 1989 to that in 1990?
Provide a short and direct response. 1.41. What is the ratio of the % of value added in manufacturing of Mauritius in 1989 to that in 1990?
Offer a very short reply. 0.99. What is the ratio of the % of value added in manufacturing of Hungary in 1989 to that in 1991?
Your response must be concise. 1.19. What is the ratio of the % of value added in manufacturing of Indonesia in 1989 to that in 1991?
Offer a terse response. 0.78. What is the ratio of the % of value added in manufacturing in Jordan in 1989 to that in 1991?
Provide a short and direct response. 1.25. What is the ratio of the % of value added in manufacturing in Mauritius in 1989 to that in 1991?
Give a very brief answer. 0.91. What is the ratio of the % of value added in manufacturing of Hungary in 1989 to that in 1992?
Give a very brief answer. 1.37. What is the ratio of the % of value added in manufacturing of Indonesia in 1989 to that in 1992?
Your answer should be very brief. 0.94. What is the ratio of the % of value added in manufacturing in Jordan in 1989 to that in 1992?
Ensure brevity in your answer.  1.27. What is the ratio of the % of value added in manufacturing in Mauritius in 1989 to that in 1992?
Offer a terse response. 1.02. What is the ratio of the % of value added in manufacturing in Hungary in 1989 to that in 1993?
Make the answer very short. 1.26. What is the ratio of the % of value added in manufacturing of Indonesia in 1989 to that in 1993?
Offer a very short reply. 0.99. What is the ratio of the % of value added in manufacturing of Jordan in 1989 to that in 1993?
Your answer should be very brief. 1.57. What is the ratio of the % of value added in manufacturing in Mauritius in 1989 to that in 1993?
Ensure brevity in your answer.  0.97. What is the ratio of the % of value added in manufacturing of Hungary in 1989 to that in 1994?
Ensure brevity in your answer.  1.12. What is the ratio of the % of value added in manufacturing of Indonesia in 1989 to that in 1994?
Offer a very short reply. 0.96. What is the ratio of the % of value added in manufacturing in Jordan in 1989 to that in 1994?
Ensure brevity in your answer.  1.53. What is the ratio of the % of value added in manufacturing of Mauritius in 1989 to that in 1994?
Give a very brief answer. 1.04. What is the ratio of the % of value added in manufacturing of Hungary in 1990 to that in 1991?
Offer a very short reply. 1.11. What is the ratio of the % of value added in manufacturing of Indonesia in 1990 to that in 1991?
Provide a short and direct response. 0.8. What is the ratio of the % of value added in manufacturing in Jordan in 1990 to that in 1991?
Provide a succinct answer. 0.88. What is the ratio of the % of value added in manufacturing in Mauritius in 1990 to that in 1991?
Ensure brevity in your answer.  0.92. What is the ratio of the % of value added in manufacturing of Hungary in 1990 to that in 1992?
Provide a succinct answer. 1.27. What is the ratio of the % of value added in manufacturing in Indonesia in 1990 to that in 1992?
Give a very brief answer. 0.97. What is the ratio of the % of value added in manufacturing in Jordan in 1990 to that in 1992?
Offer a terse response. 0.9. What is the ratio of the % of value added in manufacturing in Mauritius in 1990 to that in 1992?
Offer a very short reply. 1.02. What is the ratio of the % of value added in manufacturing in Hungary in 1990 to that in 1993?
Your answer should be compact. 1.17. What is the ratio of the % of value added in manufacturing of Indonesia in 1990 to that in 1993?
Offer a very short reply. 1.01. What is the ratio of the % of value added in manufacturing of Jordan in 1990 to that in 1993?
Ensure brevity in your answer.  1.11. What is the ratio of the % of value added in manufacturing in Mauritius in 1990 to that in 1993?
Provide a succinct answer. 0.97. What is the ratio of the % of value added in manufacturing of Hungary in 1990 to that in 1994?
Your response must be concise. 1.04. What is the ratio of the % of value added in manufacturing of Jordan in 1990 to that in 1994?
Your response must be concise. 1.08. What is the ratio of the % of value added in manufacturing of Mauritius in 1990 to that in 1994?
Keep it short and to the point. 1.04. What is the ratio of the % of value added in manufacturing of Hungary in 1991 to that in 1992?
Keep it short and to the point. 1.15. What is the ratio of the % of value added in manufacturing in Indonesia in 1991 to that in 1992?
Offer a very short reply. 1.21. What is the ratio of the % of value added in manufacturing in Jordan in 1991 to that in 1992?
Offer a terse response. 1.02. What is the ratio of the % of value added in manufacturing in Mauritius in 1991 to that in 1992?
Keep it short and to the point. 1.11. What is the ratio of the % of value added in manufacturing in Hungary in 1991 to that in 1993?
Provide a short and direct response. 1.06. What is the ratio of the % of value added in manufacturing in Indonesia in 1991 to that in 1993?
Provide a short and direct response. 1.27. What is the ratio of the % of value added in manufacturing of Jordan in 1991 to that in 1993?
Provide a short and direct response. 1.26. What is the ratio of the % of value added in manufacturing in Mauritius in 1991 to that in 1993?
Provide a succinct answer. 1.06. What is the ratio of the % of value added in manufacturing in Hungary in 1991 to that in 1994?
Keep it short and to the point. 0.94. What is the ratio of the % of value added in manufacturing in Indonesia in 1991 to that in 1994?
Provide a succinct answer. 1.24. What is the ratio of the % of value added in manufacturing in Jordan in 1991 to that in 1994?
Ensure brevity in your answer.  1.22. What is the ratio of the % of value added in manufacturing of Mauritius in 1991 to that in 1994?
Offer a terse response. 1.13. What is the ratio of the % of value added in manufacturing of Hungary in 1992 to that in 1993?
Provide a short and direct response. 0.92. What is the ratio of the % of value added in manufacturing of Indonesia in 1992 to that in 1993?
Offer a very short reply. 1.04. What is the ratio of the % of value added in manufacturing in Jordan in 1992 to that in 1993?
Your response must be concise. 1.24. What is the ratio of the % of value added in manufacturing in Mauritius in 1992 to that in 1993?
Provide a short and direct response. 0.95. What is the ratio of the % of value added in manufacturing of Hungary in 1992 to that in 1994?
Offer a very short reply. 0.82. What is the ratio of the % of value added in manufacturing in Indonesia in 1992 to that in 1994?
Ensure brevity in your answer.  1.02. What is the ratio of the % of value added in manufacturing in Jordan in 1992 to that in 1994?
Ensure brevity in your answer.  1.2. What is the ratio of the % of value added in manufacturing of Mauritius in 1992 to that in 1994?
Make the answer very short. 1.02. What is the ratio of the % of value added in manufacturing in Hungary in 1993 to that in 1994?
Your answer should be very brief. 0.89. What is the ratio of the % of value added in manufacturing of Indonesia in 1993 to that in 1994?
Provide a succinct answer. 0.97. What is the ratio of the % of value added in manufacturing of Jordan in 1993 to that in 1994?
Your response must be concise. 0.97. What is the ratio of the % of value added in manufacturing of Mauritius in 1993 to that in 1994?
Make the answer very short. 1.07. What is the difference between the highest and the second highest % of value added in manufacturing in Hungary?
Keep it short and to the point. 0.94. What is the difference between the highest and the second highest % of value added in manufacturing in Indonesia?
Offer a very short reply. 0.8. What is the difference between the highest and the second highest % of value added in manufacturing of Jordan?
Keep it short and to the point. 4.2. What is the difference between the highest and the second highest % of value added in manufacturing of Mauritius?
Provide a short and direct response. 0.2. What is the difference between the highest and the lowest % of value added in manufacturing of Hungary?
Ensure brevity in your answer.  4.39. What is the difference between the highest and the lowest % of value added in manufacturing of Indonesia?
Your answer should be very brief. 2.5. What is the difference between the highest and the lowest % of value added in manufacturing in Jordan?
Keep it short and to the point. 9.9. What is the difference between the highest and the lowest % of value added in manufacturing in Mauritius?
Offer a very short reply. 0.54. 